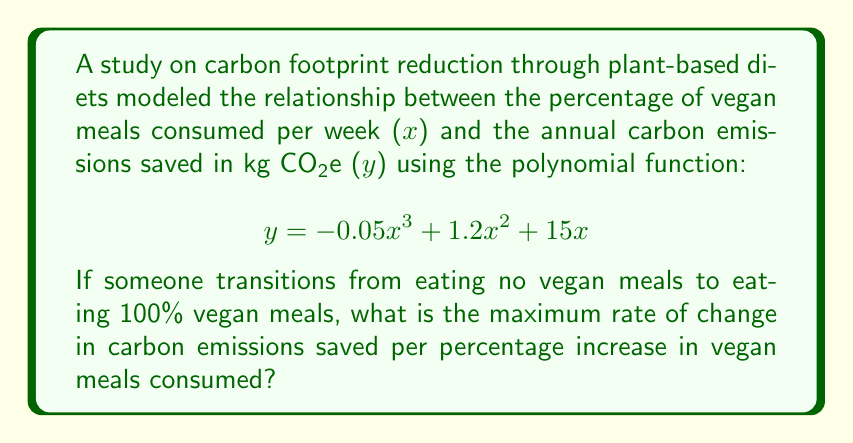Could you help me with this problem? To find the maximum rate of change, we need to follow these steps:

1) First, we need to find the derivative of the given function:
   $$y = -0.05x^3 + 1.2x^2 + 15x$$
   $$\frac{dy}{dx} = -0.15x^2 + 2.4x + 15$$

2) The maximum rate of change occurs at the highest point of the derivative function. To find this, we need to find the vertex of this quadratic function.

3) For a quadratic function in the form $ax^2 + bx + c$, the x-coordinate of the vertex is given by $-\frac{b}{2a}$:

   $a = -0.15$, $b = 2.4$

   $x = -\frac{2.4}{2(-0.15)} = 8$

4) Now, we need to plug this x-value back into our derivative function to find the maximum rate of change:

   $$\frac{dy}{dx} = -0.15(8)^2 + 2.4(8) + 15$$
   $$= -0.15(64) + 19.2 + 15$$
   $$= -9.6 + 19.2 + 15$$
   $$= 24.6$$

5) Therefore, the maximum rate of change is 24.6 kg CO2e saved per percentage increase in vegan meals consumed.
Answer: 24.6 kg CO2e/% 